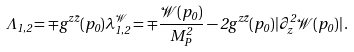<formula> <loc_0><loc_0><loc_500><loc_500>\Lambda _ { 1 , 2 } = \mp g ^ { z \bar { z } } ( p _ { 0 } ) \lambda ^ { \mathcal { W } } _ { 1 , 2 } = \mp \frac { { \mathcal { W } } ( p _ { 0 } ) } { M _ { P } ^ { 2 } } - 2 g ^ { z \bar { z } } ( p _ { 0 } ) | \partial ^ { 2 } _ { z } { \mathcal { W } } ( p _ { 0 } ) | \, .</formula> 